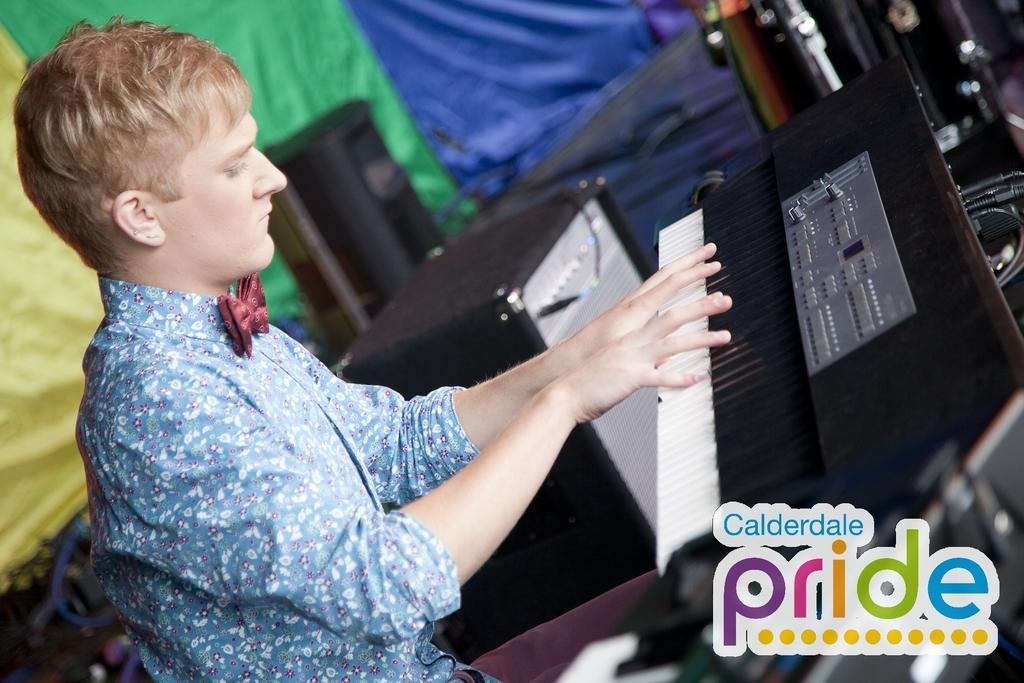What is the person in the image doing? The person in the image is playing a musical instrument. What can be seen in the image besides the person playing the instrument? There are sound boxes visible in the image. What is the purpose of the cloth at the back of the scene? The purpose of the cloth at the back of the scene is not clear from the provided facts. How many grapes are on the table in the image? There is no table or grapes present in the image. What type of party is being depicted in the image? There is no party depicted in the image; it features a person playing a musical instrument and sound boxes. 